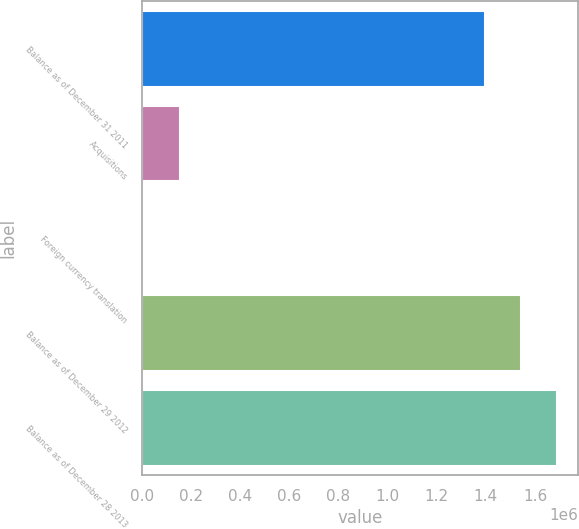Convert chart to OTSL. <chart><loc_0><loc_0><loc_500><loc_500><bar_chart><fcel>Balance as of December 31 2011<fcel>Acquisitions<fcel>Foreign currency translation<fcel>Balance as of December 29 2012<fcel>Balance as of December 28 2013<nl><fcel>1.39825e+06<fcel>155452<fcel>9909<fcel>1.54379e+06<fcel>1.68933e+06<nl></chart> 